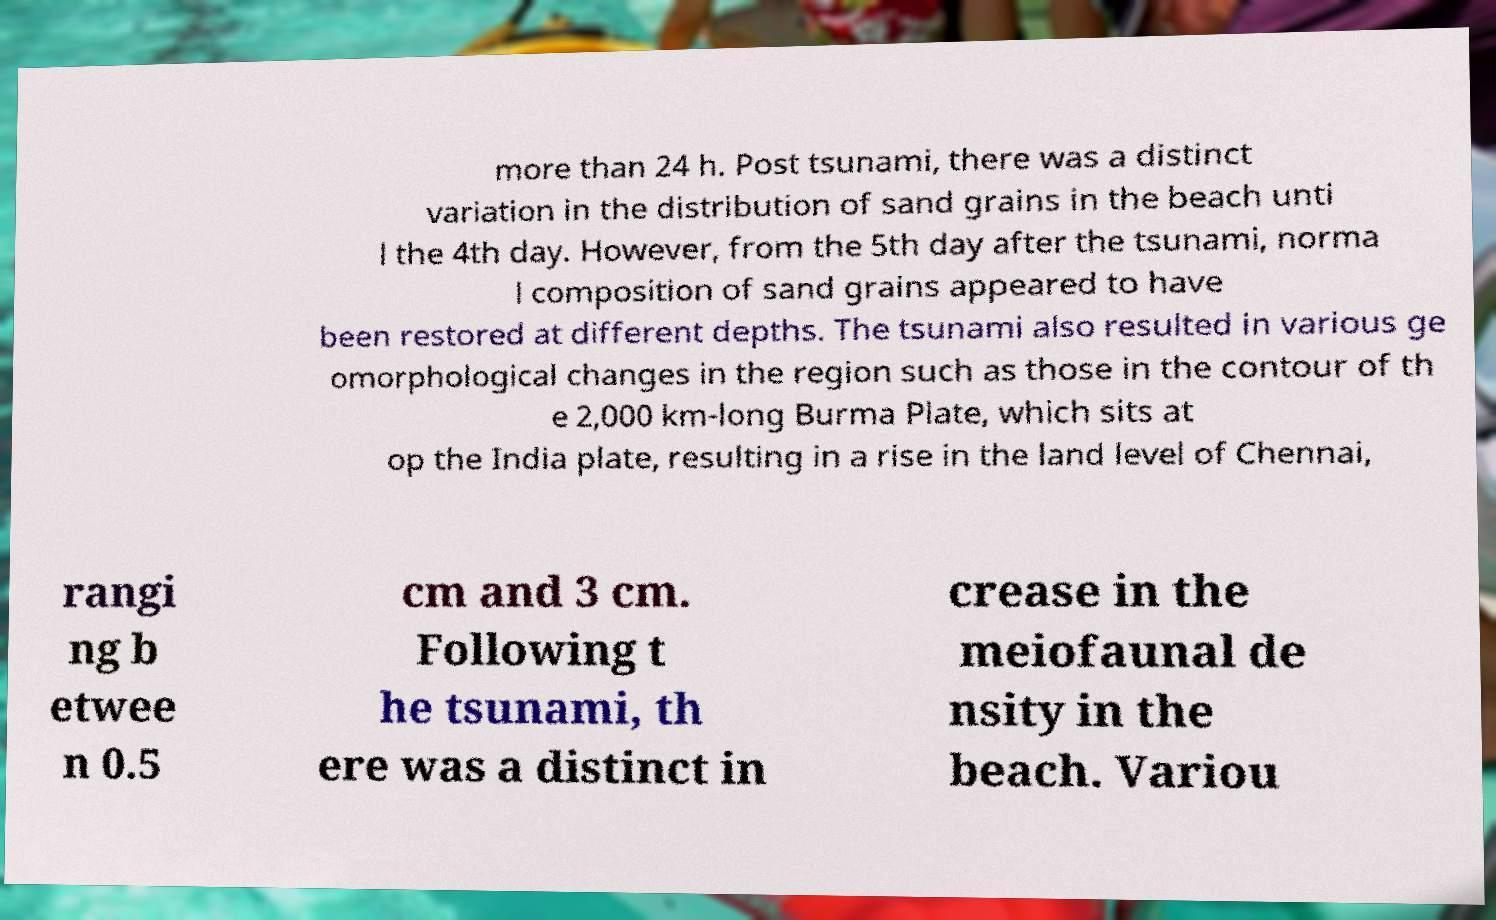For documentation purposes, I need the text within this image transcribed. Could you provide that? more than 24 h. Post tsunami, there was a distinct variation in the distribution of sand grains in the beach unti l the 4th day. However, from the 5th day after the tsunami, norma l composition of sand grains appeared to have been restored at different depths. The tsunami also resulted in various ge omorphological changes in the region such as those in the contour of th e 2,000 km-long Burma Plate, which sits at op the India plate, resulting in a rise in the land level of Chennai, rangi ng b etwee n 0.5 cm and 3 cm. Following t he tsunami, th ere was a distinct in crease in the meiofaunal de nsity in the beach. Variou 